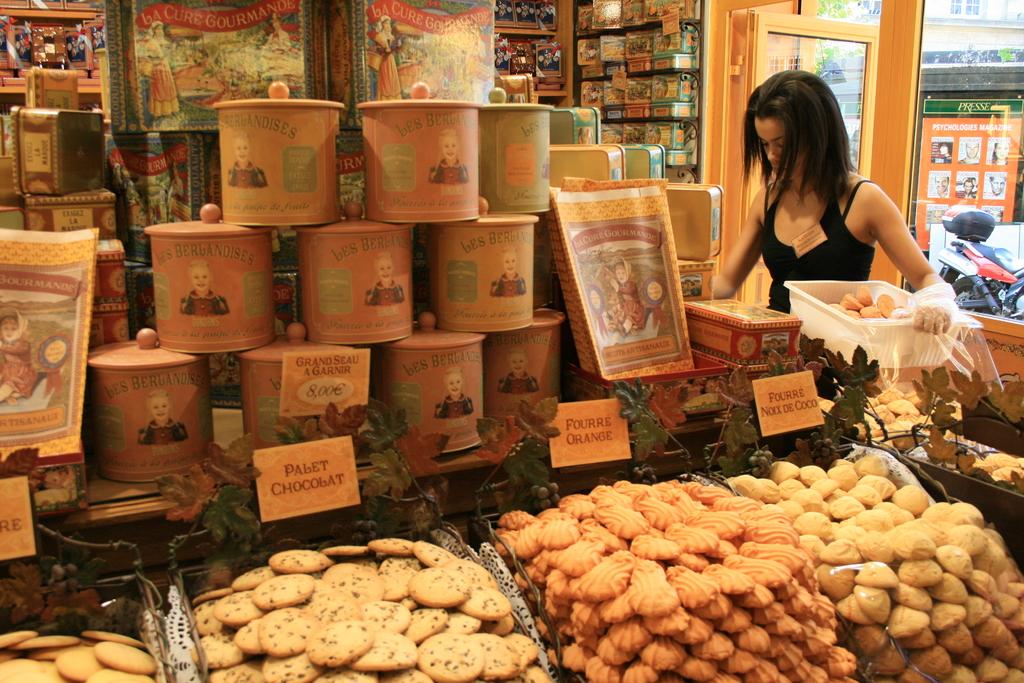What is the name of the cookies on the right?
Ensure brevity in your answer.  Fourre noxx de coco. 